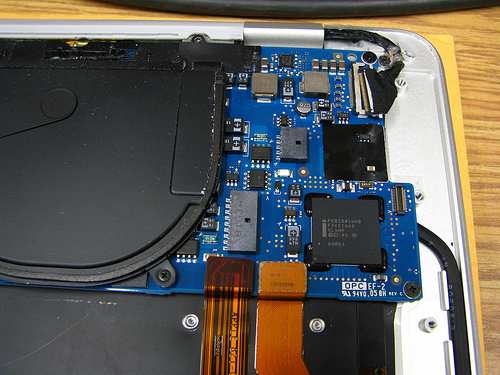<image>
Is the processor next to the board? Yes. The processor is positioned adjacent to the board, located nearby in the same general area. 